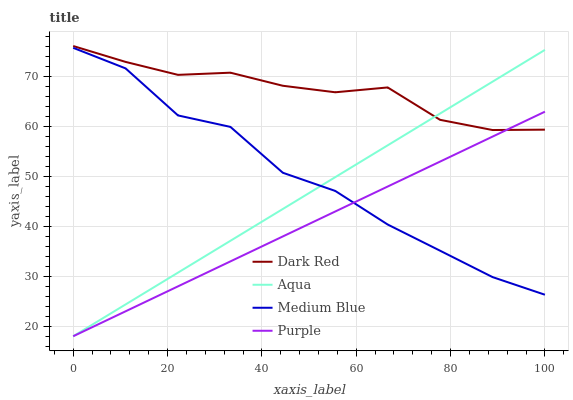Does Purple have the minimum area under the curve?
Answer yes or no. Yes. Does Dark Red have the maximum area under the curve?
Answer yes or no. Yes. Does Aqua have the minimum area under the curve?
Answer yes or no. No. Does Aqua have the maximum area under the curve?
Answer yes or no. No. Is Aqua the smoothest?
Answer yes or no. Yes. Is Medium Blue the roughest?
Answer yes or no. Yes. Is Dark Red the smoothest?
Answer yes or no. No. Is Dark Red the roughest?
Answer yes or no. No. Does Dark Red have the lowest value?
Answer yes or no. No. Does Aqua have the highest value?
Answer yes or no. No. Is Medium Blue less than Dark Red?
Answer yes or no. Yes. Is Dark Red greater than Medium Blue?
Answer yes or no. Yes. Does Medium Blue intersect Dark Red?
Answer yes or no. No. 